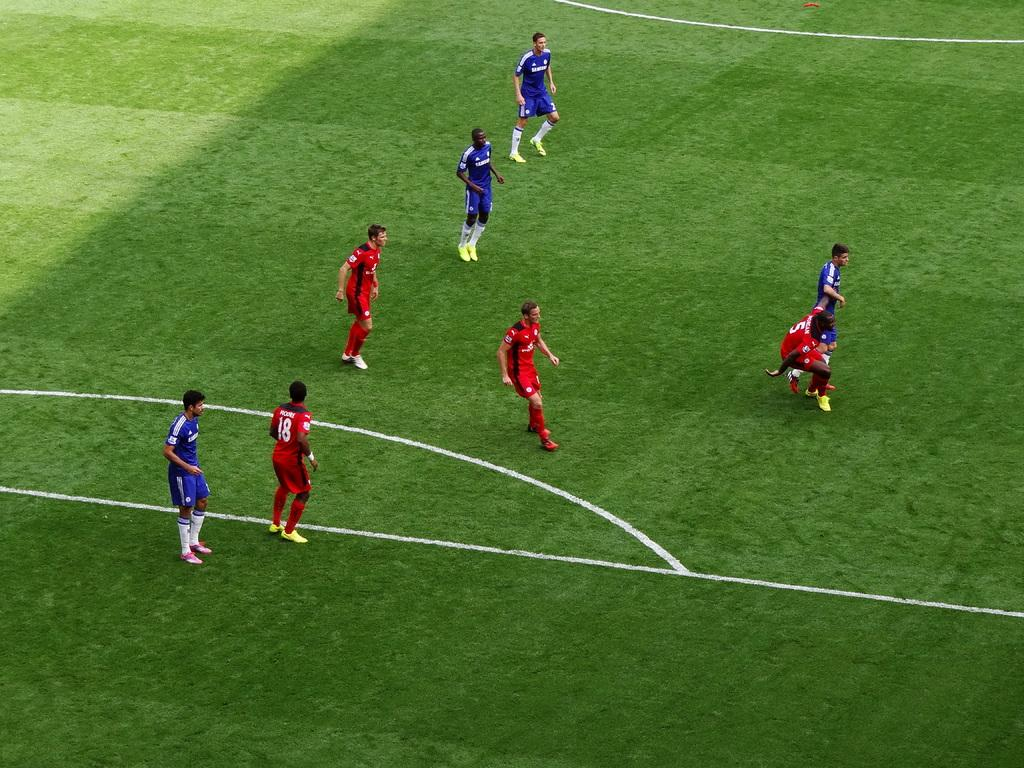<image>
Offer a succinct explanation of the picture presented. A player wearing red with number 5 on the back falls to the ground. 